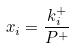Convert formula to latex. <formula><loc_0><loc_0><loc_500><loc_500>x _ { i } = \frac { k _ { i } ^ { + } } { P ^ { + } }</formula> 